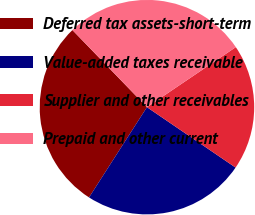Convert chart. <chart><loc_0><loc_0><loc_500><loc_500><pie_chart><fcel>Deferred tax assets-short-term<fcel>Value-added taxes receivable<fcel>Supplier and other receivables<fcel>Prepaid and other current<nl><fcel>28.69%<fcel>24.56%<fcel>18.98%<fcel>27.77%<nl></chart> 